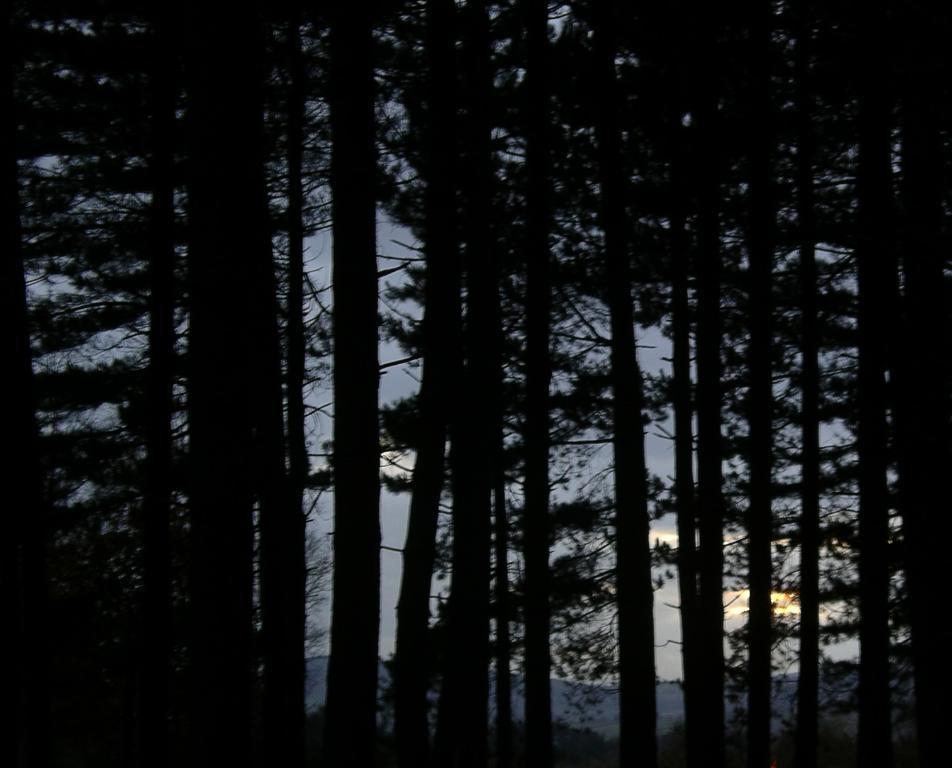Please provide a concise description of this image. In this picture we can see there are trees and behind the trees there is a sky. 